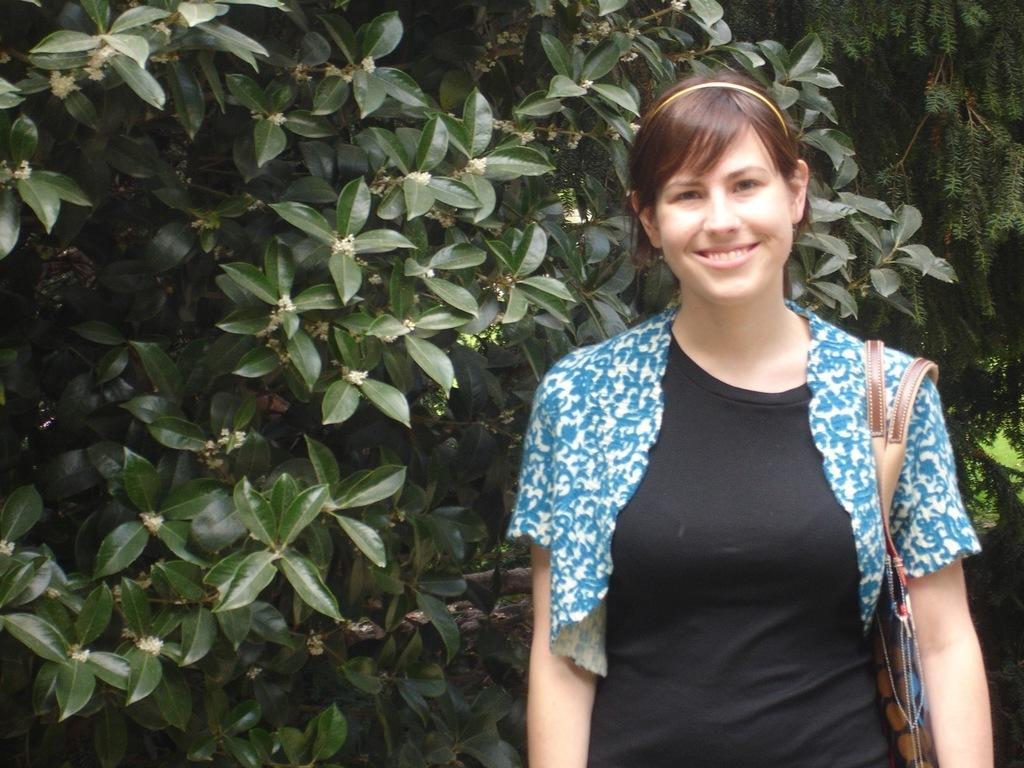Who is the main subject in the image? There is a woman in the image. Where is the woman located in the image? The woman is standing on the right side of the image. What expression does the woman have? The woman is smiling. What is the woman carrying in the image? The woman is wearing a bag. What can be seen in the background of the image? There are trees in the background of the image. What type of horn can be heard in the image? There is no horn present in the image, and therefore no sound can be heard. 